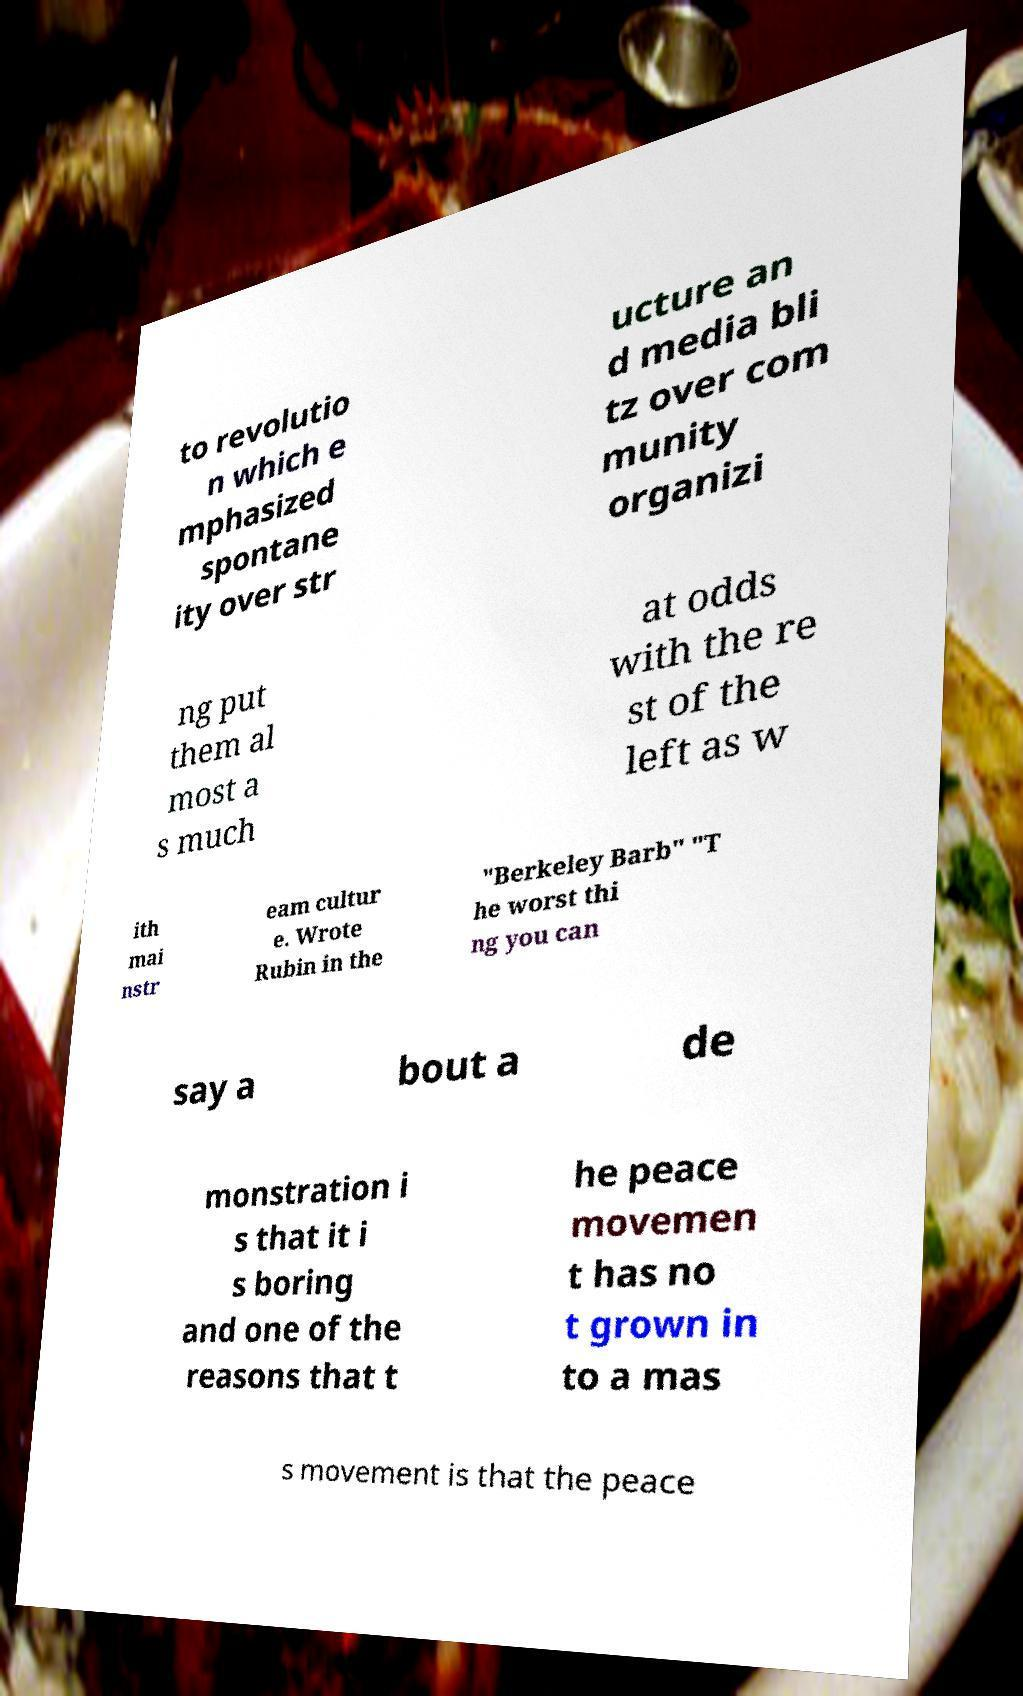There's text embedded in this image that I need extracted. Can you transcribe it verbatim? to revolutio n which e mphasized spontane ity over str ucture an d media bli tz over com munity organizi ng put them al most a s much at odds with the re st of the left as w ith mai nstr eam cultur e. Wrote Rubin in the "Berkeley Barb" "T he worst thi ng you can say a bout a de monstration i s that it i s boring and one of the reasons that t he peace movemen t has no t grown in to a mas s movement is that the peace 